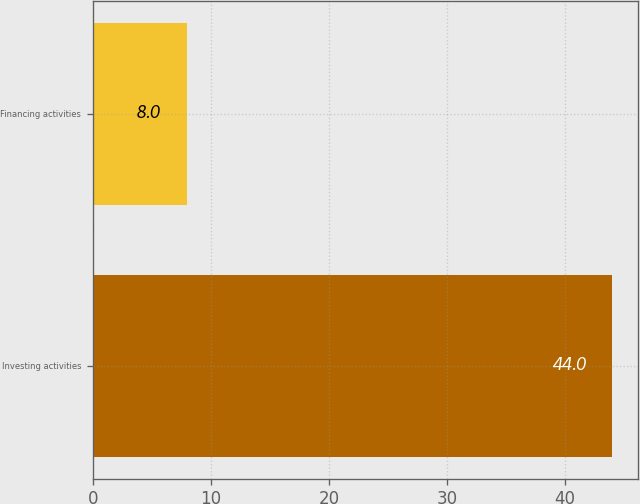<chart> <loc_0><loc_0><loc_500><loc_500><bar_chart><fcel>Investing activities<fcel>Financing activities<nl><fcel>44<fcel>8<nl></chart> 